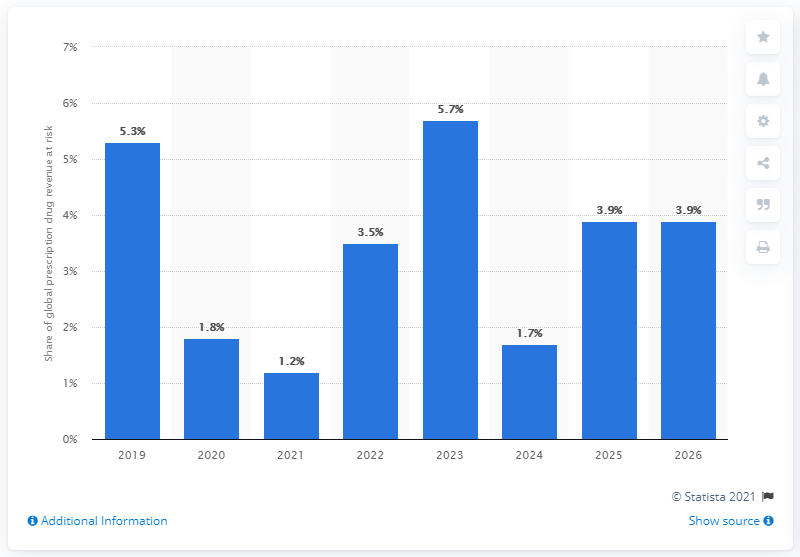Specify some key components in this picture. In 2019, a significant percentage of the market was at risk due to patent expirations, with the exact figure being 5.3%. 